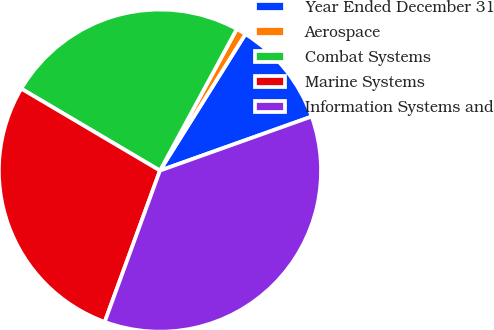Convert chart to OTSL. <chart><loc_0><loc_0><loc_500><loc_500><pie_chart><fcel>Year Ended December 31<fcel>Aerospace<fcel>Combat Systems<fcel>Marine Systems<fcel>Information Systems and<nl><fcel>10.65%<fcel>0.99%<fcel>24.42%<fcel>27.92%<fcel>36.02%<nl></chart> 